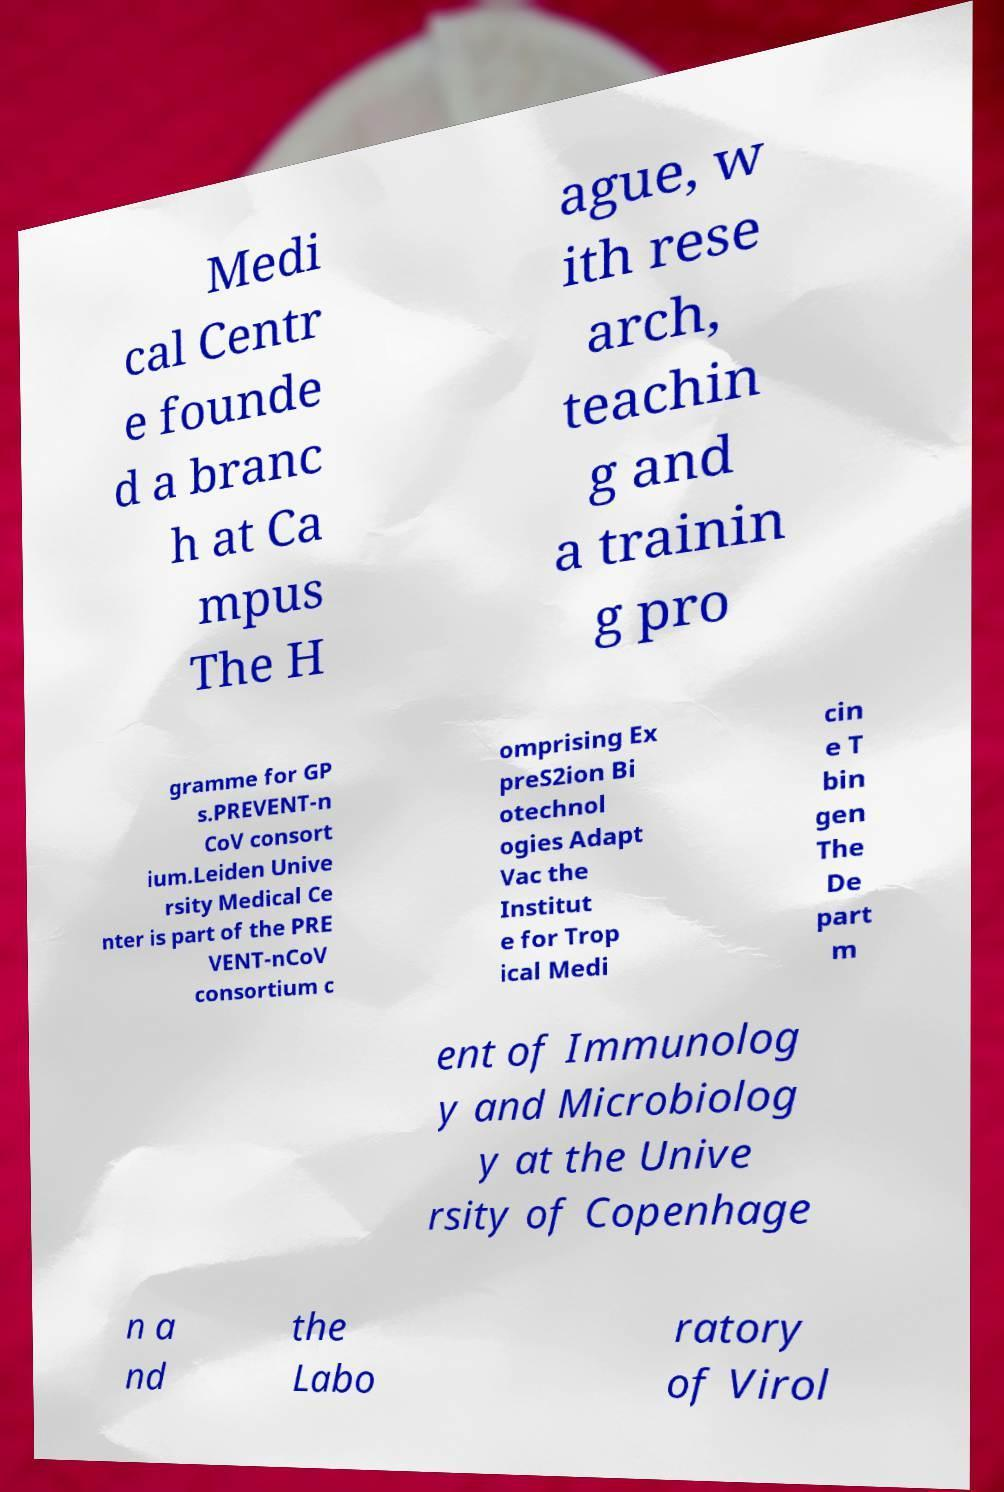For documentation purposes, I need the text within this image transcribed. Could you provide that? Medi cal Centr e founde d a branc h at Ca mpus The H ague, w ith rese arch, teachin g and a trainin g pro gramme for GP s.PREVENT-n CoV consort ium.Leiden Unive rsity Medical Ce nter is part of the PRE VENT-nCoV consortium c omprising Ex preS2ion Bi otechnol ogies Adapt Vac the Institut e for Trop ical Medi cin e T bin gen The De part m ent of Immunolog y and Microbiolog y at the Unive rsity of Copenhage n a nd the Labo ratory of Virol 